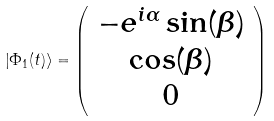<formula> <loc_0><loc_0><loc_500><loc_500>\left | \Phi _ { 1 } ( t ) \right \rangle = \left ( \begin{array} { c l r r } - e ^ { i \alpha } \sin ( \beta ) \\ \cos ( \beta ) \\ 0 \end{array} \right )</formula> 